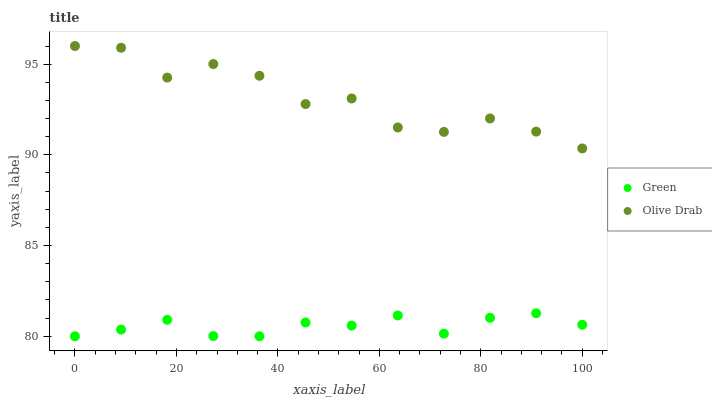Does Green have the minimum area under the curve?
Answer yes or no. Yes. Does Olive Drab have the maximum area under the curve?
Answer yes or no. Yes. Does Olive Drab have the minimum area under the curve?
Answer yes or no. No. Is Green the smoothest?
Answer yes or no. Yes. Is Olive Drab the roughest?
Answer yes or no. Yes. Is Olive Drab the smoothest?
Answer yes or no. No. Does Green have the lowest value?
Answer yes or no. Yes. Does Olive Drab have the lowest value?
Answer yes or no. No. Does Olive Drab have the highest value?
Answer yes or no. Yes. Is Green less than Olive Drab?
Answer yes or no. Yes. Is Olive Drab greater than Green?
Answer yes or no. Yes. Does Green intersect Olive Drab?
Answer yes or no. No. 